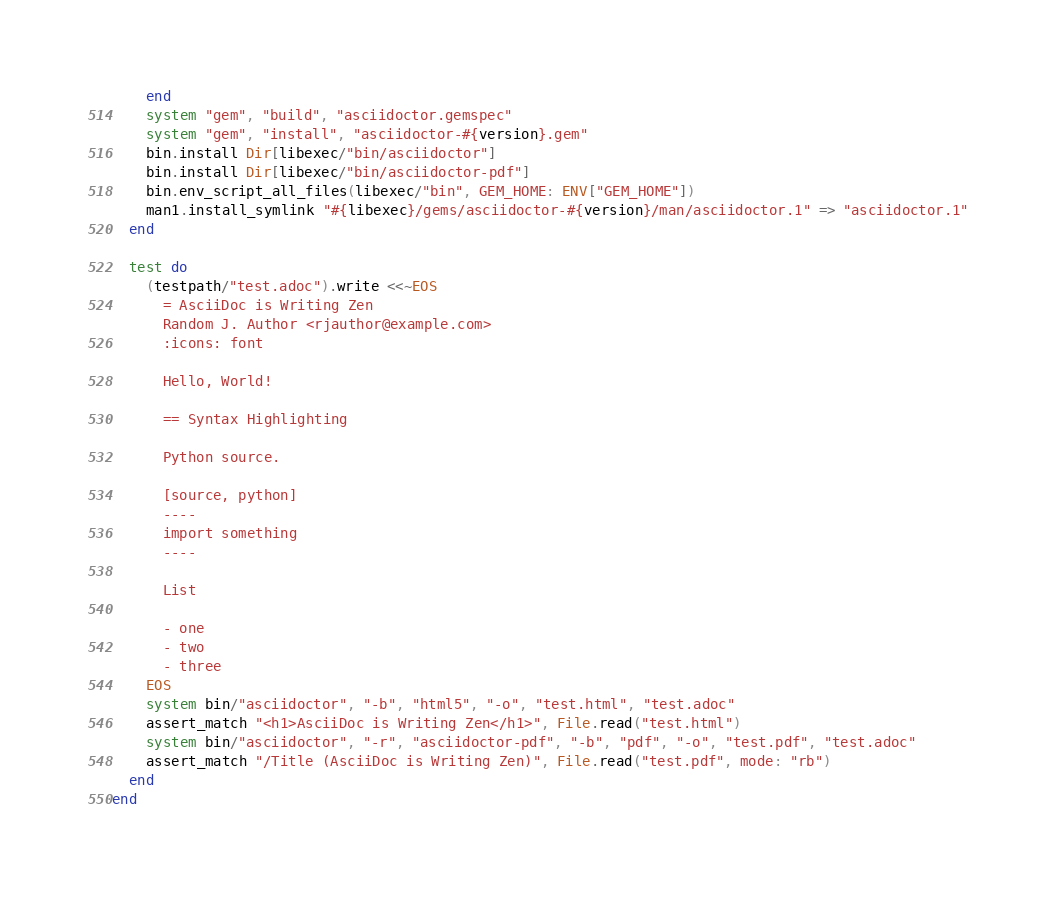Convert code to text. <code><loc_0><loc_0><loc_500><loc_500><_Ruby_>    end
    system "gem", "build", "asciidoctor.gemspec"
    system "gem", "install", "asciidoctor-#{version}.gem"
    bin.install Dir[libexec/"bin/asciidoctor"]
    bin.install Dir[libexec/"bin/asciidoctor-pdf"]
    bin.env_script_all_files(libexec/"bin", GEM_HOME: ENV["GEM_HOME"])
    man1.install_symlink "#{libexec}/gems/asciidoctor-#{version}/man/asciidoctor.1" => "asciidoctor.1"
  end

  test do
    (testpath/"test.adoc").write <<~EOS
      = AsciiDoc is Writing Zen
      Random J. Author <rjauthor@example.com>
      :icons: font

      Hello, World!

      == Syntax Highlighting

      Python source.

      [source, python]
      ----
      import something
      ----

      List

      - one
      - two
      - three
    EOS
    system bin/"asciidoctor", "-b", "html5", "-o", "test.html", "test.adoc"
    assert_match "<h1>AsciiDoc is Writing Zen</h1>", File.read("test.html")
    system bin/"asciidoctor", "-r", "asciidoctor-pdf", "-b", "pdf", "-o", "test.pdf", "test.adoc"
    assert_match "/Title (AsciiDoc is Writing Zen)", File.read("test.pdf", mode: "rb")
  end
end
</code> 